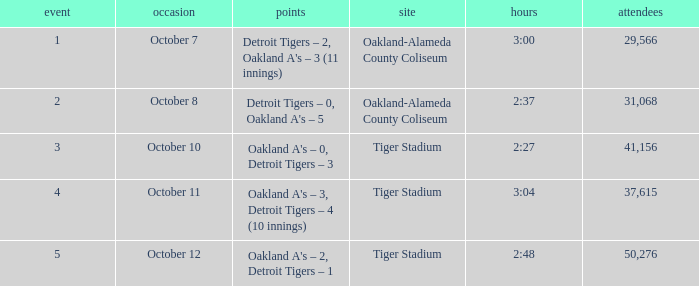What is the number of people in attendance at Oakland-Alameda County Coliseum, and game is 2? 31068.0. 